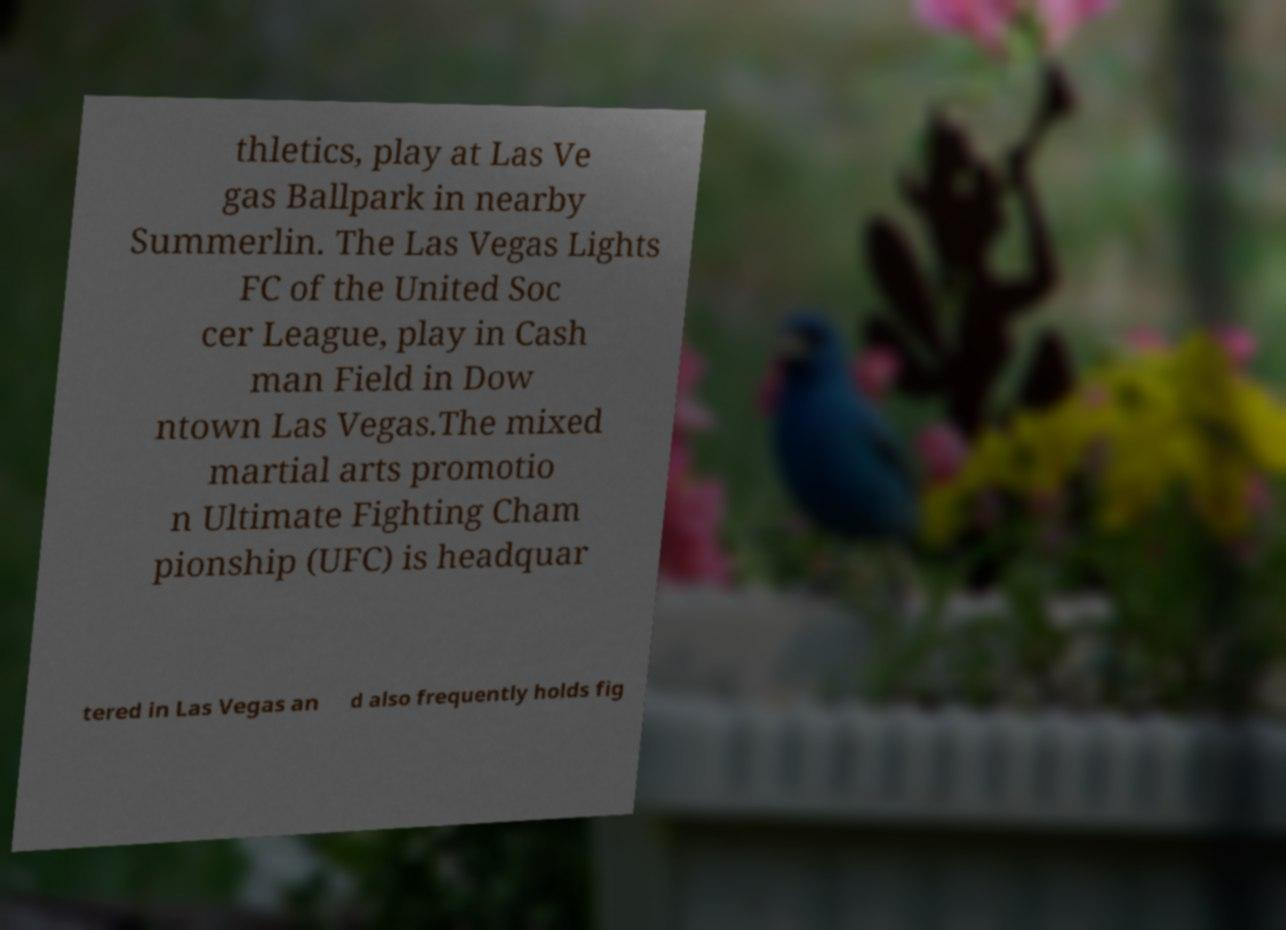Please identify and transcribe the text found in this image. thletics, play at Las Ve gas Ballpark in nearby Summerlin. The Las Vegas Lights FC of the United Soc cer League, play in Cash man Field in Dow ntown Las Vegas.The mixed martial arts promotio n Ultimate Fighting Cham pionship (UFC) is headquar tered in Las Vegas an d also frequently holds fig 